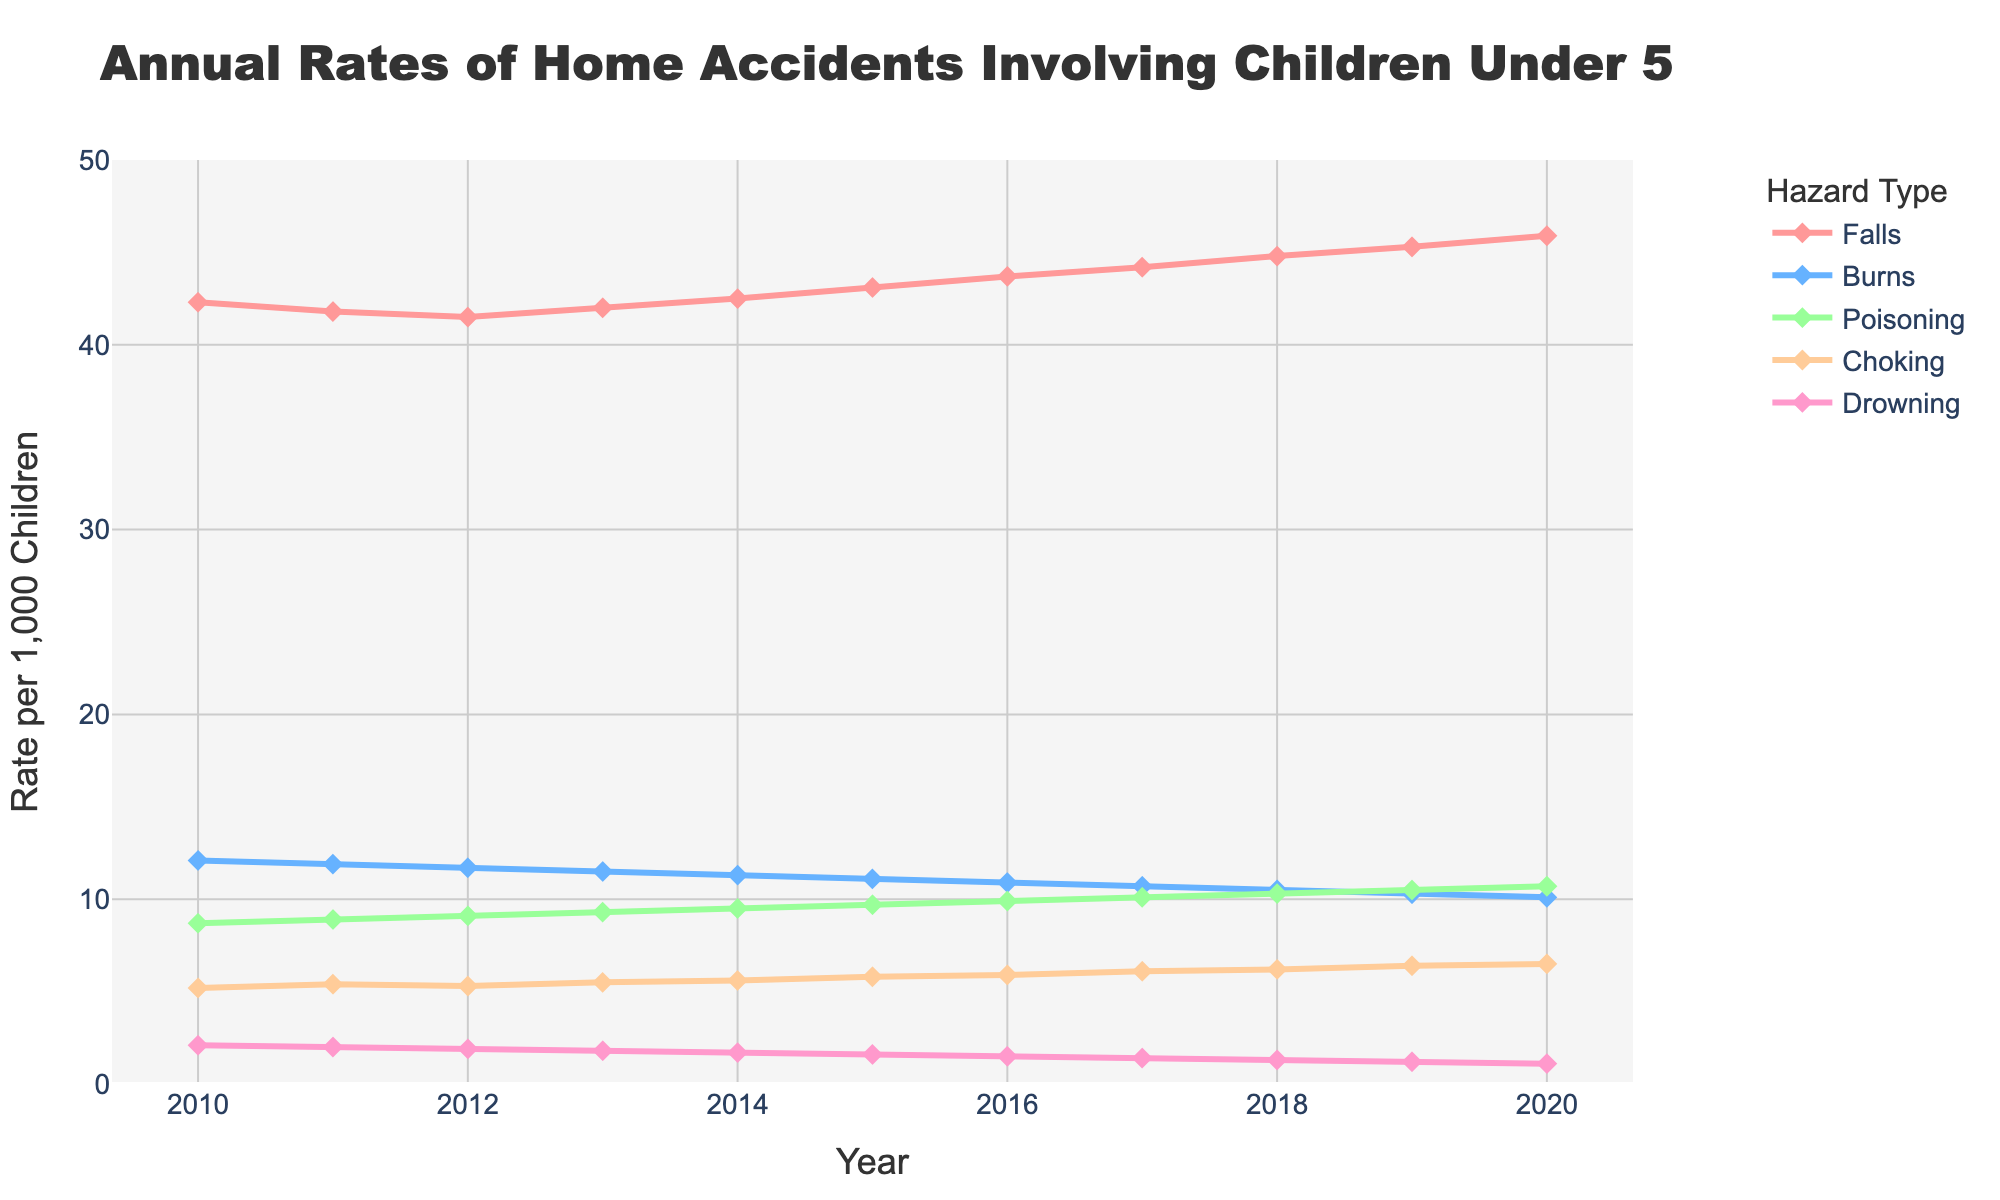What's the overall trend for fall-related accidents from 2010 to 2020? Observing the line corresponding to fall-related accidents, it shows a gradual increase every year from 42.3 in 2010 to 45.9 in 2020.
Answer: Gradual increase Which year had the highest rate of poisoning accidents? The line for poisoning accidents peaks at 10.7 in the year 2020, indicating that 2020 has the highest rate of poisoning accidents.
Answer: 2020 Between burns and drowning, which hazard type saw the most significant decrease in the rate of accidents from 2010 to 2020? Comparing the decrease, burns went from 12.1 in 2010 to 10.1 in 2020 (a decrease of 2.0), while drowning went from 2.1 to 1.1 (a decrease of 1.0). Therefore, burns saw a more significant decrease.
Answer: Burns What is the difference in the rate of fall-related accidents between 2010 and 2015? The rate of falls in 2010 is 42.3, and in 2015 it's 43.1. The difference is calculated as 43.1 - 42.3 = 0.8.
Answer: 0.8 What is the average rate of choking accidents over the entire period? Summing the rates of choking from 2010 to 2020 gives 62.9. Dividing this by 11 years, we get an average of 62.9 / 11 ≈ 5.7.
Answer: 5.7 Which hazard had the most stable rate over the entire period? Visually examining the lines, choking rates show the least fluctuation from 5.2 to 6.5 compared to others.
Answer: Choking Among the years shown, which year had the lowest total accident rate across all hazards? Adding the rates of all hazards for each year, 2020 has the totals: 45.9 + 10.1 + 10.7 + 6.5 + 1.1 = 74.3, which is higher than other years, indicating it didn’t have the lowest total. Checking others, 2010’s total is 42.3 + 12.1 + 8.7 + 5.2 + 2.1 = 70.4, which indeed is the lowest.
Answer: 2010 